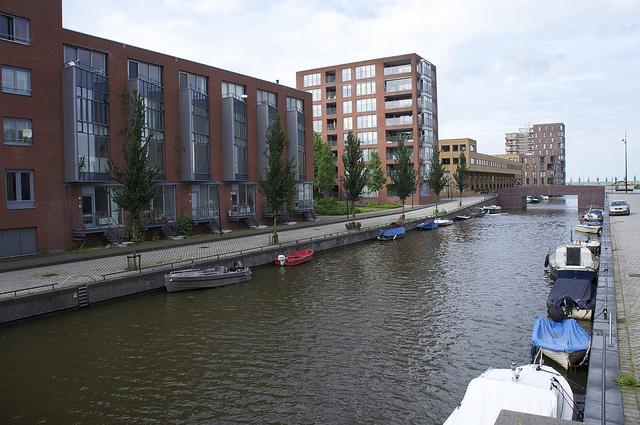Are all of the boats parked?
Short answer required. Yes. How many cars are parked next to the canal?
Quick response, please. 1. What is parked in the water?
Quick response, please. Boats. 